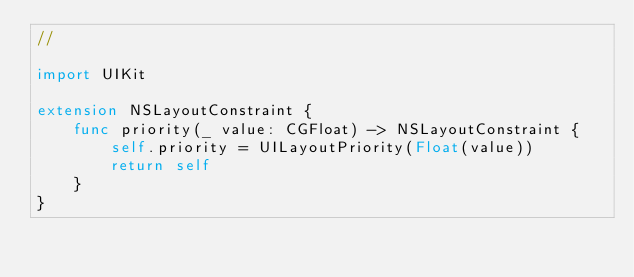Convert code to text. <code><loc_0><loc_0><loc_500><loc_500><_Swift_>//

import UIKit

extension NSLayoutConstraint {
    func priority(_ value: CGFloat) -> NSLayoutConstraint {
        self.priority = UILayoutPriority(Float(value))
        return self
    }
}
</code> 